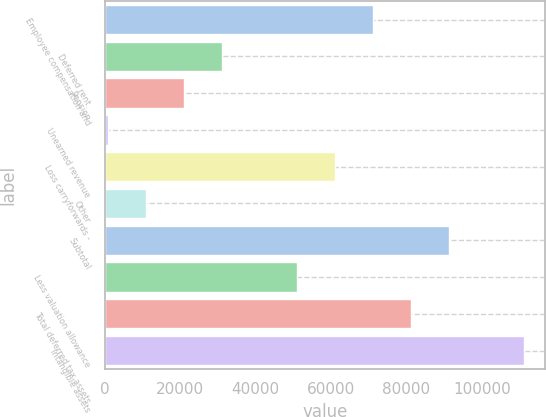Convert chart to OTSL. <chart><loc_0><loc_0><loc_500><loc_500><bar_chart><fcel>Employee compensation and<fcel>Deferred rent<fcel>Pension<fcel>Unearned revenue<fcel>Loss carryforwards -<fcel>Other<fcel>Subtotal<fcel>Less valuation allowance<fcel>Total deferred tax assets<fcel>Intangible assets<nl><fcel>71170.1<fcel>30988.9<fcel>20943.6<fcel>853<fcel>61124.8<fcel>10898.3<fcel>91260.7<fcel>51079.5<fcel>81215.4<fcel>111351<nl></chart> 